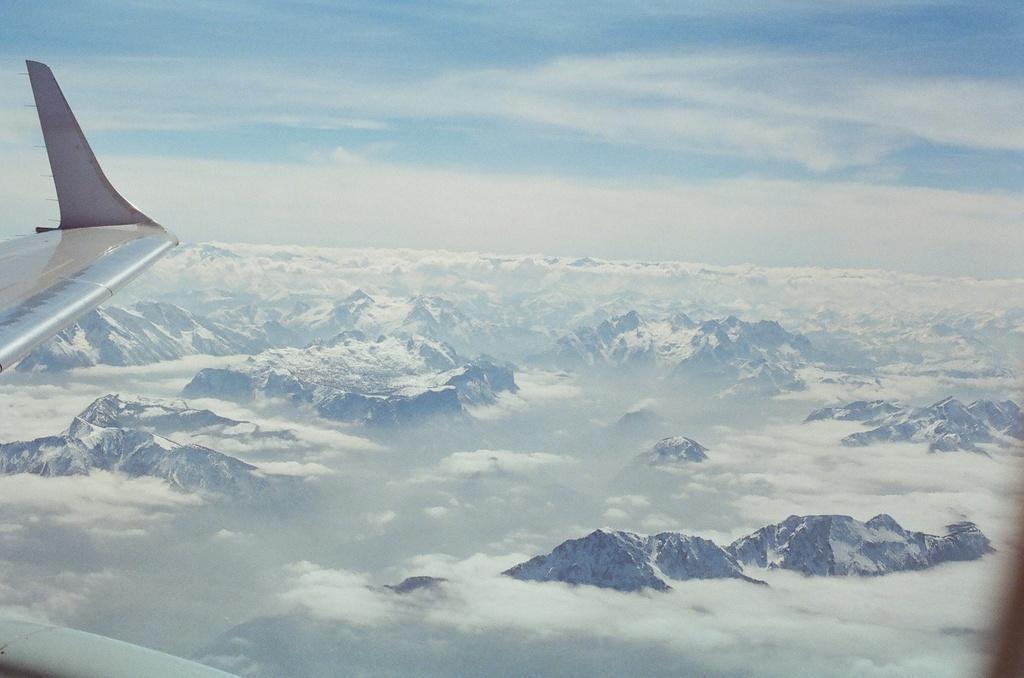Describe this image in one or two sentences. On the left side of the mage there is a wing of a plane. And there are mountains covered with snow and also there are clouds. At the top of the image there is sky with clouds. 